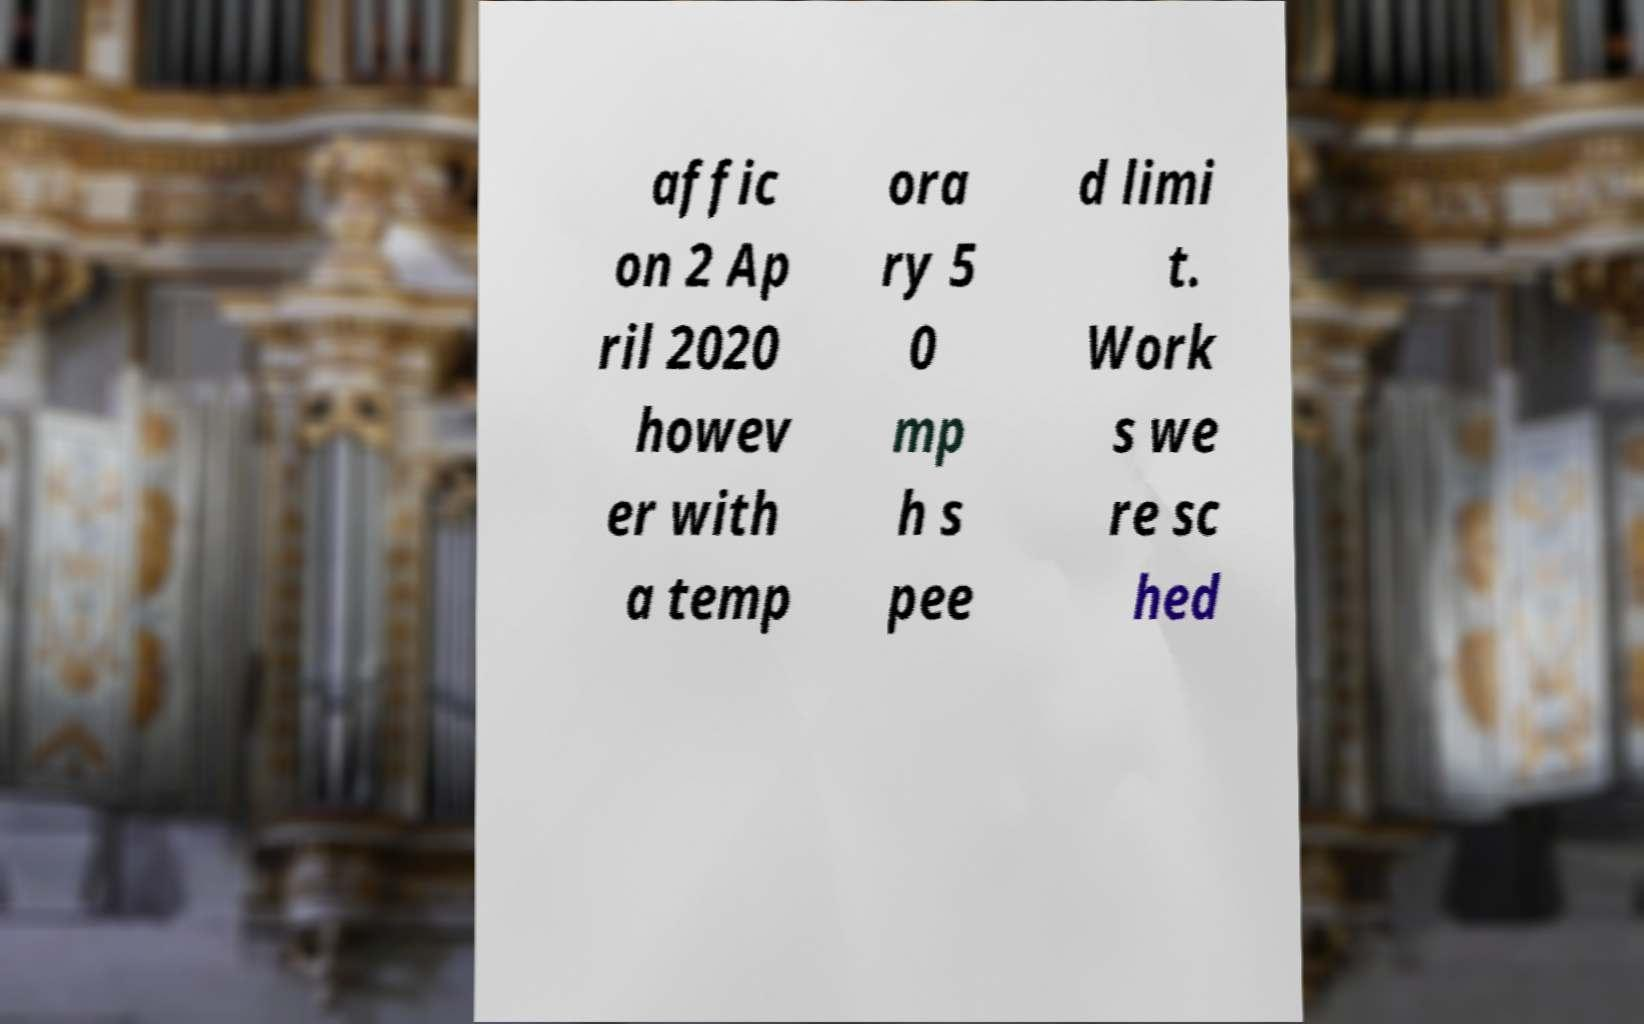Please read and relay the text visible in this image. What does it say? affic on 2 Ap ril 2020 howev er with a temp ora ry 5 0 mp h s pee d limi t. Work s we re sc hed 